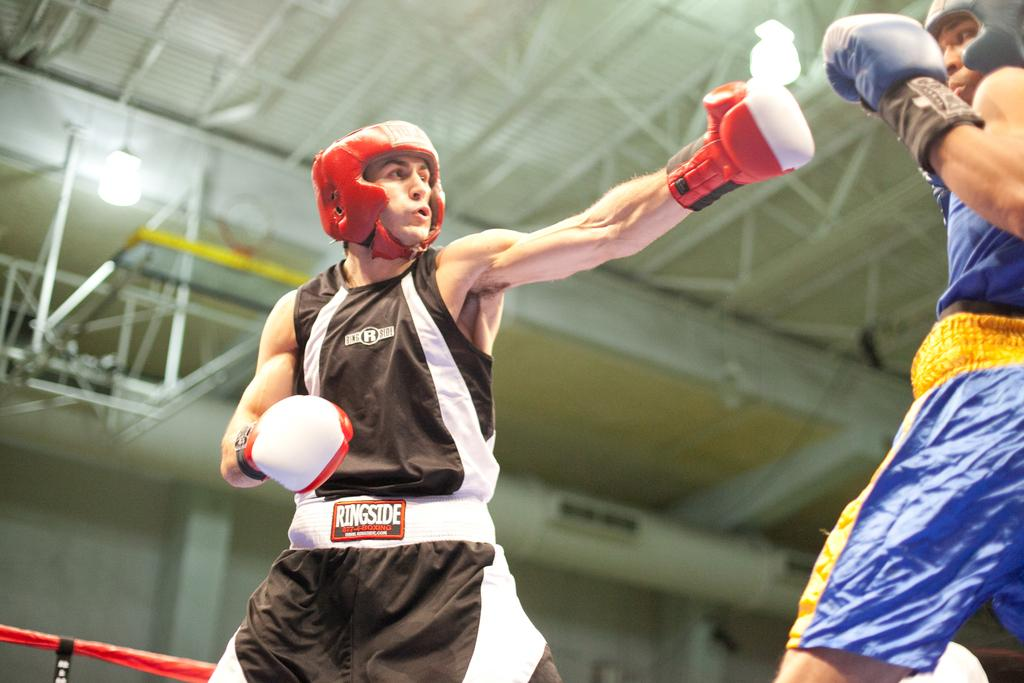What are the two persons in the foreground of the image doing? The two persons in the foreground of the image are boxing. What can be seen in the background of the image? There is a shed and a light in the background of the image. What is the answer to the question asked by the person in the scene from history? There is no person asking a question in the image, nor is there any reference to a scene from history. 